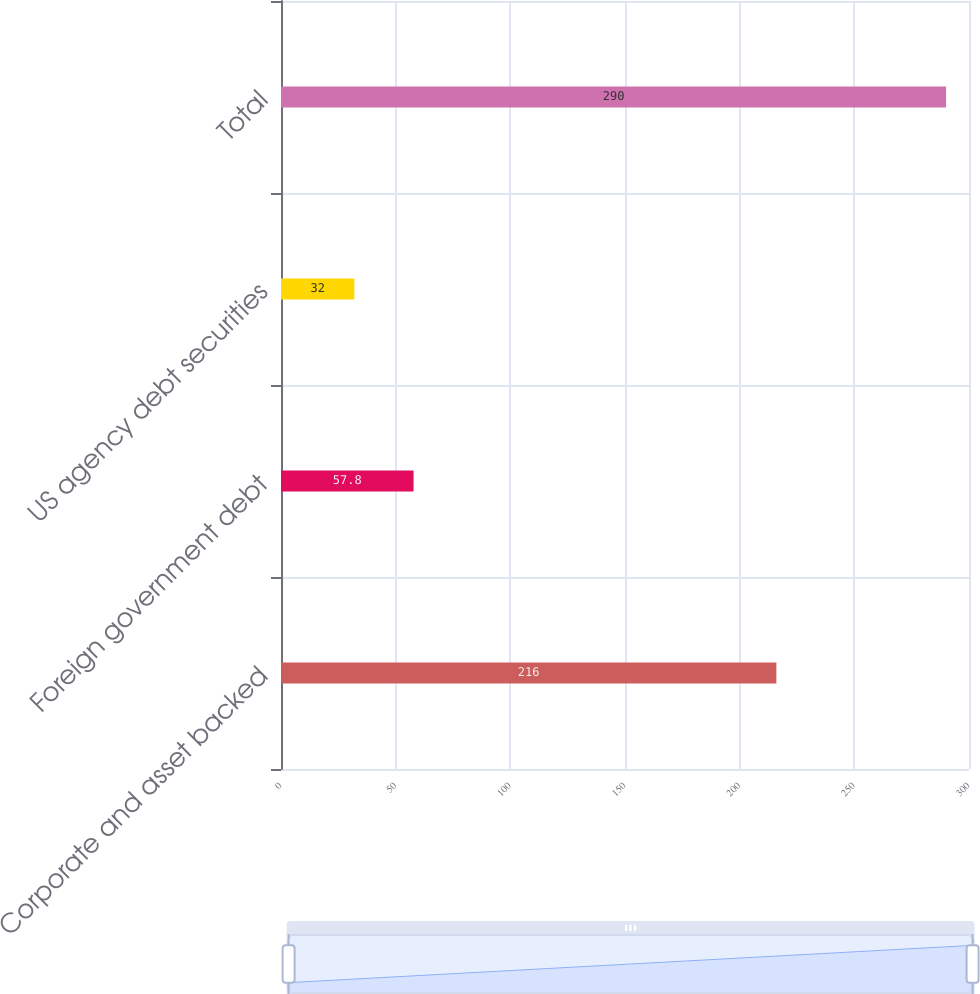Convert chart to OTSL. <chart><loc_0><loc_0><loc_500><loc_500><bar_chart><fcel>Corporate and asset backed<fcel>Foreign government debt<fcel>US agency debt securities<fcel>Total<nl><fcel>216<fcel>57.8<fcel>32<fcel>290<nl></chart> 